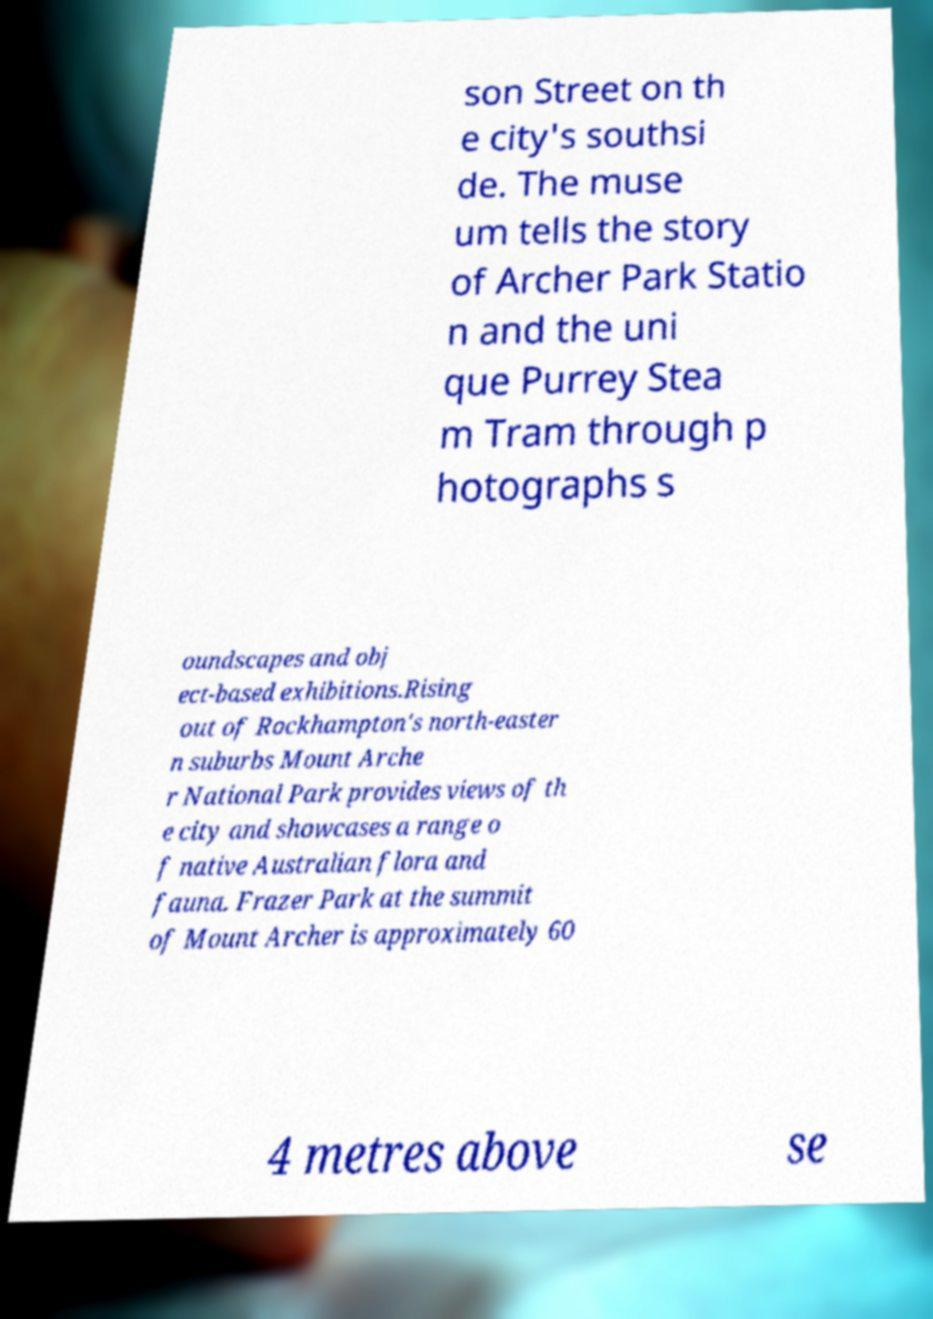Can you accurately transcribe the text from the provided image for me? son Street on th e city's southsi de. The muse um tells the story of Archer Park Statio n and the uni que Purrey Stea m Tram through p hotographs s oundscapes and obj ect-based exhibitions.Rising out of Rockhampton's north-easter n suburbs Mount Arche r National Park provides views of th e city and showcases a range o f native Australian flora and fauna. Frazer Park at the summit of Mount Archer is approximately 60 4 metres above se 